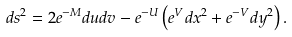Convert formula to latex. <formula><loc_0><loc_0><loc_500><loc_500>d s ^ { 2 } = 2 e ^ { - M } d u d v - e ^ { - U } \left ( e ^ { V } d x ^ { 2 } + e ^ { - V } d y ^ { 2 } \right ) .</formula> 